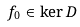Convert formula to latex. <formula><loc_0><loc_0><loc_500><loc_500>f _ { 0 } \in \ker D</formula> 